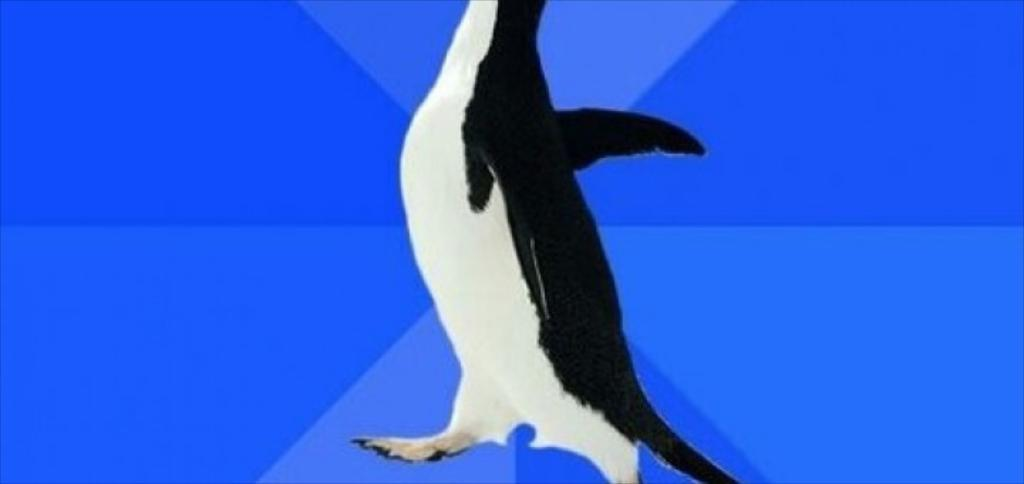What type of animal is in the image? There is an animal in the image, but the specific type cannot be determined from the provided facts. What colors are present on the animal in the image? The animal is black and white in color. What color is the background of the image? The background of the image is blue. What is the name of the band playing in the background of the image? There is no band present in the image, so it is not possible to determine the name of any band. 